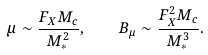<formula> <loc_0><loc_0><loc_500><loc_500>\mu \sim \frac { F _ { X } M _ { c } } { M ^ { 2 } _ { * } } , \quad B _ { \mu } \sim \frac { F _ { X } ^ { 2 } M _ { c } } { M ^ { 3 } _ { * } } .</formula> 